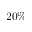Convert formula to latex. <formula><loc_0><loc_0><loc_500><loc_500>2 0 \%</formula> 